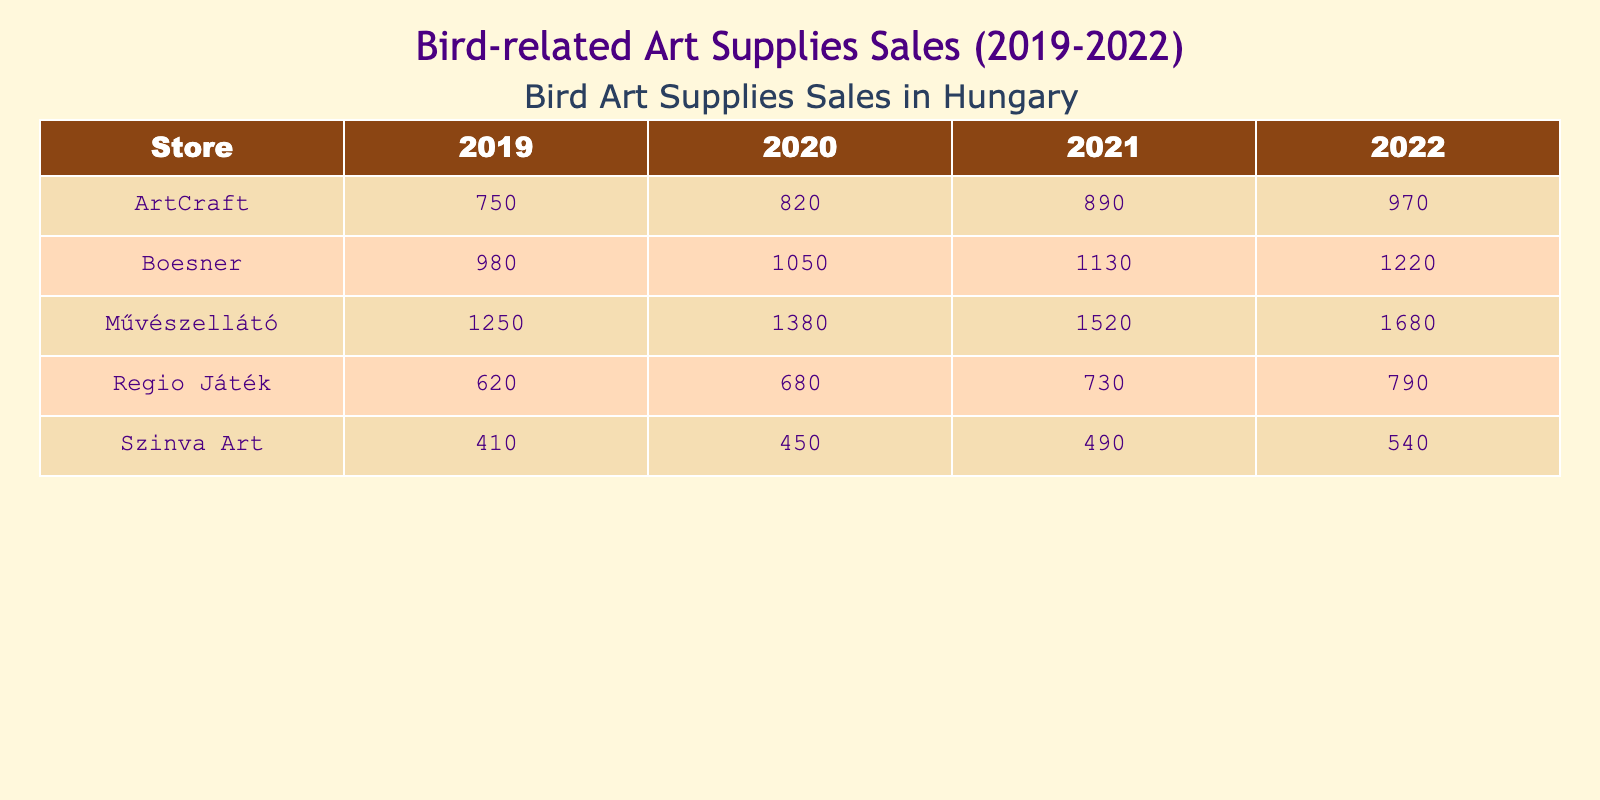What were the sales of Faber-Castell Colored Pencils in 2020? The sales figure for Faber-Castell Colored Pencils in 2020 is directly listed under the Művészellátó store and the year 2020, which shows a value of 1380.
Answer: 1380 Which store had the highest sales of Winsor & Newton Watercolors in 2022? In 2022, the sales of Winsor & Newton Watercolors at Boesner is shown, and it is the only store listed for this product, with a total of 1220 sales, making it the highest for that year.
Answer: Boesner What was the total sales for Strathmore Bird Sketchbooks from 2019 to 2022? To find the total sales, we add the sales figures for each year: 750 (2019) + 820 (2020) + 890 (2021) + 970 (2022) = 3430.
Answer: 3430 Did Regio Játék ever have sales over 800 for Derwent Drawing Pencils? By examining the sales figures for Regio Játék for Derwent Drawing Pencils, we see that the highest sales were 790 in 2022, which is below 800, confirming that they never had sales over that amount.
Answer: No What is the average yearly sales of Schmincke Horadam Gouache from 2019 to 2022? We calculate the total sales from the years: 410 (2019) + 450 (2020) + 490 (2021) + 540 (2022) = 1890. There are 4 years, so we divide 1890 by 4, yielding an average of 472.5.
Answer: 472.5 Which product had the highest sales in 2021? In 2021, the highest sales figure can be found by comparing all the listed values: Faber-Castell Colored Pencils (1520), Winsor & Newton Watercolors (1130), Strathmore Bird Sketchbooks (890), Derwent Drawing Pencils (730), and Schmincke Horadam Gouache (490). The highest is 1520 for Faber-Castell Colored Pencils.
Answer: Faber-Castell Colored Pencils What year saw the largest increase in sales for ArtCraft's Strathmore Bird Sketchbooks? To determine the year with the largest increase, we calculate the yearly increase: from 750 to 820 (+70), from 820 to 890 (+70), and from 890 to 970 (+80). The largest increase was from 890 in 2021 to 970 in 2022, which is +80.
Answer: 2022 How much more did Művészellátó sell in Faber-Castell Colored Pencils in 2022 compared to 2019? We subtract the 2019 sales (1250) from the 2022 sales (1680): 1680 - 1250 = 430. This indicates that sales increased by 430 from 2019 to 2022.
Answer: 430 In which year did Szinva Art's sales of Schmincke Horadam Gouache reach 490? By looking directly at the Szinva Art row for Schmincke Horadam Gouache, we see that it reached the value of 490 in the year 2021 as indicated in the table.
Answer: 2021 